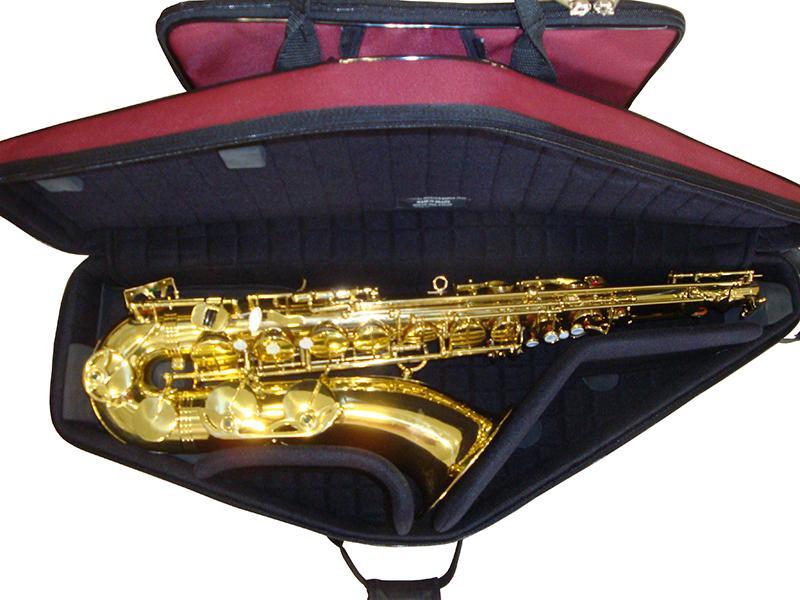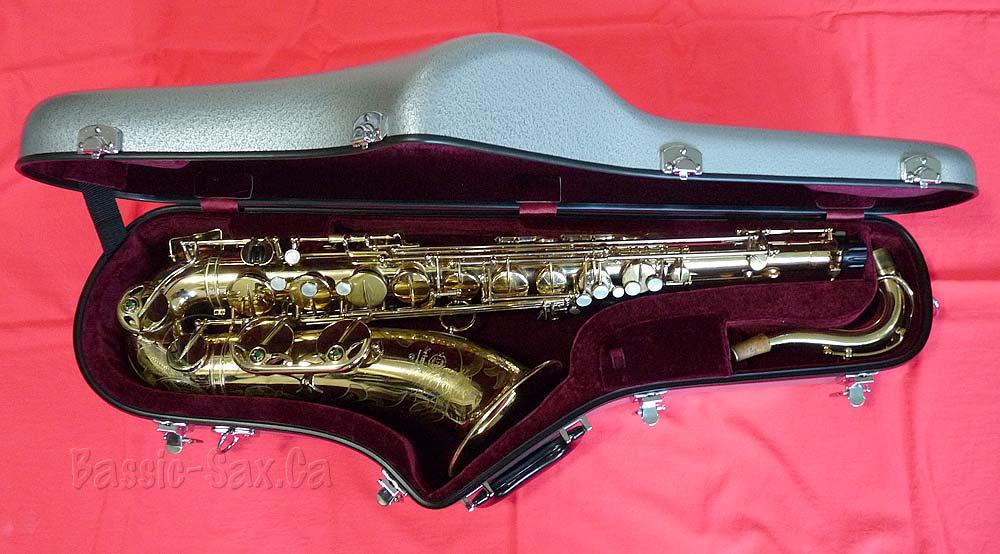The first image is the image on the left, the second image is the image on the right. Evaluate the accuracy of this statement regarding the images: "At least one saxophone case has a burgundy velvet interior.". Is it true? Answer yes or no. Yes. The first image is the image on the left, the second image is the image on the right. Given the left and right images, does the statement "An image shows a rounded, not rectangular, case, which is lined in black fabric and holds one saxophone." hold true? Answer yes or no. Yes. 